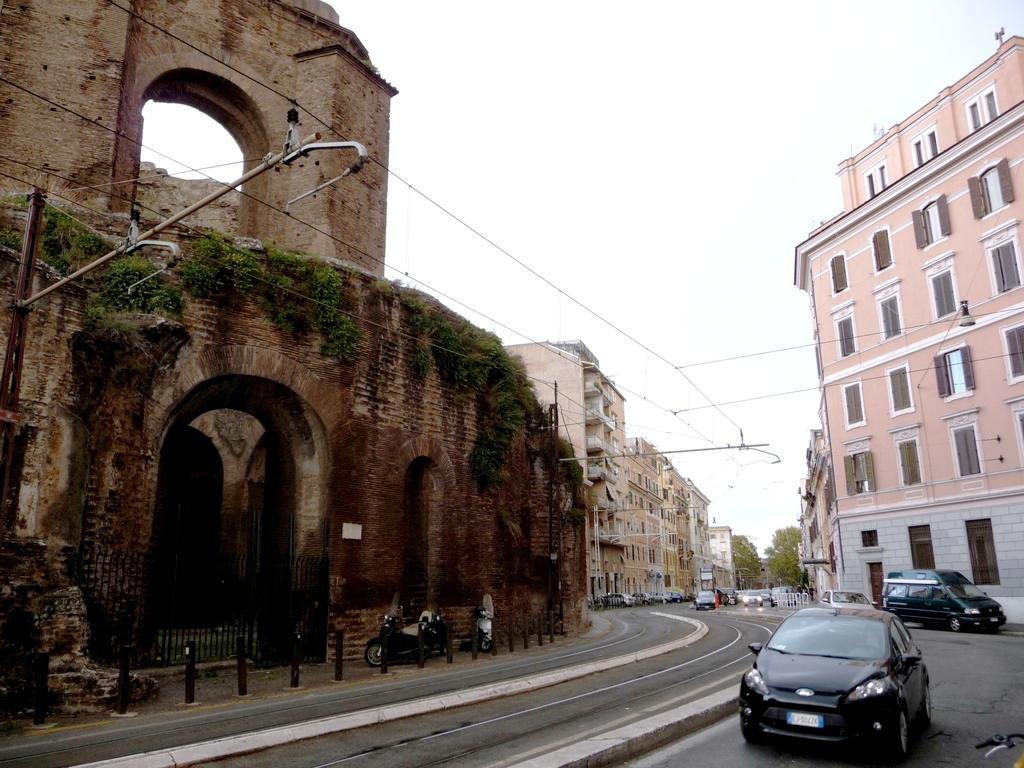What is present on the road in the image? There are vehicles on the road in the image. What can be seen in the distance behind the vehicles? There are buildings, trees, and the sky visible in the background of the image. Can you tell me how the vehicles are exchanging information in the image? The vehicles are not shown exchanging information in the image; they are simply driving on the road. Is there any indication that someone is joining the vehicles in the image? No, there is no indication that anyone is joining the vehicles in the image. 